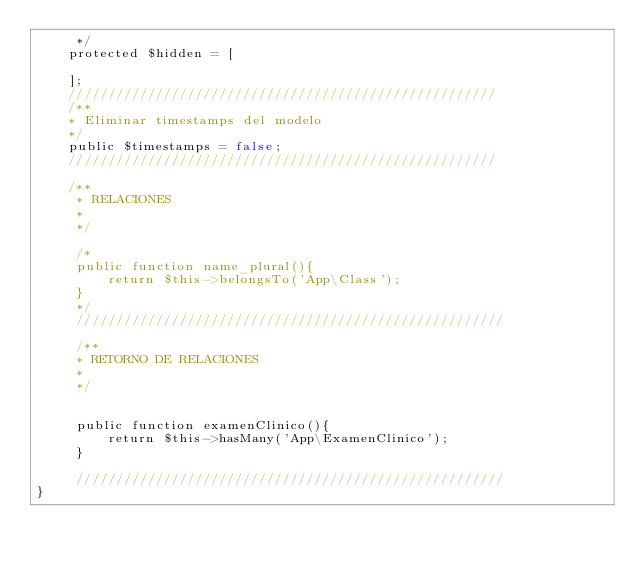Convert code to text. <code><loc_0><loc_0><loc_500><loc_500><_PHP_>     */
    protected $hidden = [
        
    ];
    //////////////////////////////////////////////////////
    /**
    * Eliminar timestamps del modelo
    */
    public $timestamps = false;
    //////////////////////////////////////////////////////

    /**
     * RELACIONES
     *
     */

     /*
     public function name_plural(){
         return $this->belongsTo('App\Class');
     }
     */
     //////////////////////////////////////////////////////

     /**
     * RETORNO DE RELACIONES
     *
     */

     
     public function examenClinico(){
         return $this->hasMany('App\ExamenClinico');
     }
     
     //////////////////////////////////////////////////////
}
</code> 